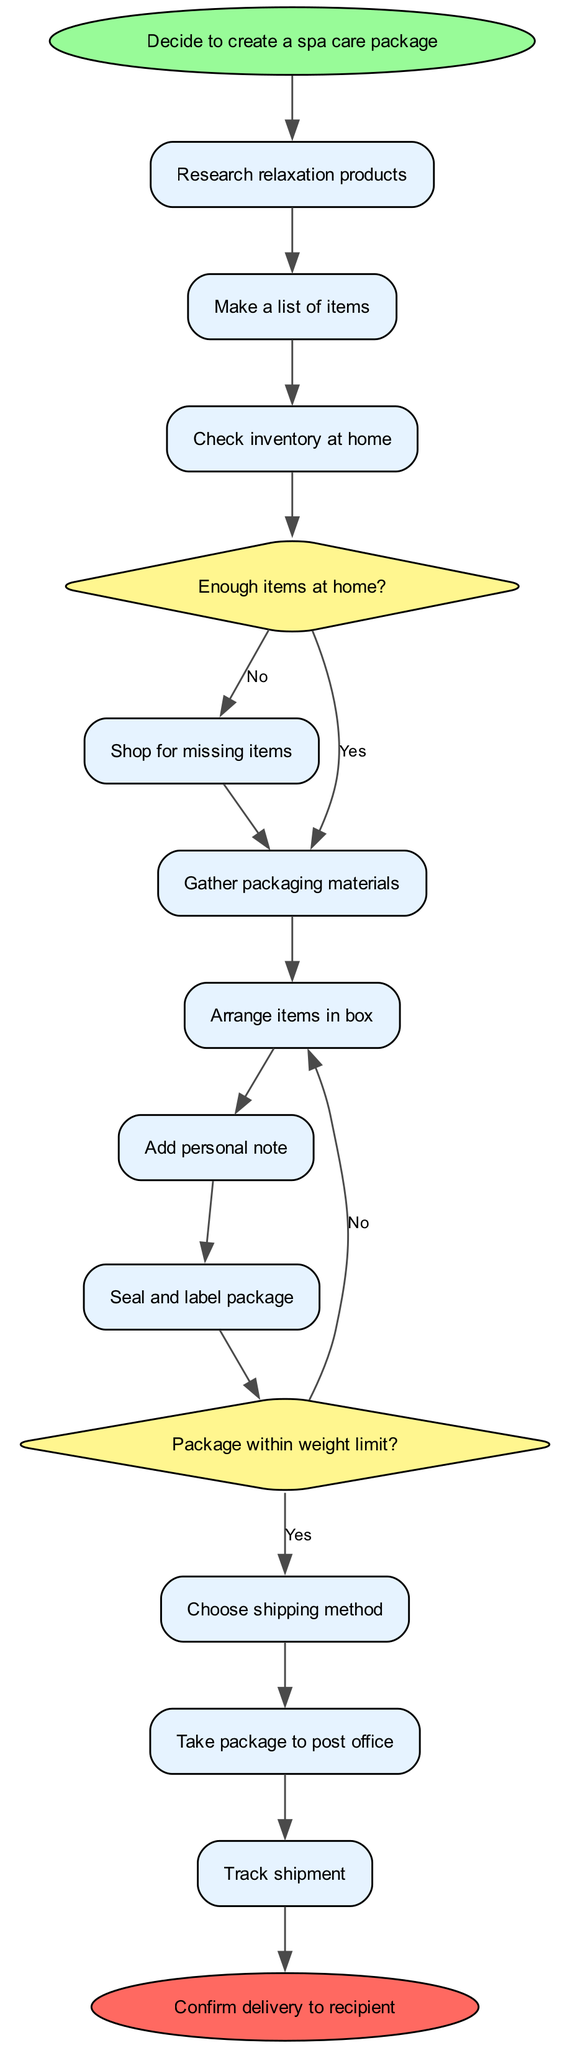What is the first step in the diagram? The first step is indicated by the 'start' node which states "Decide to create a spa care package." This is the initial action in the process.
Answer: Decide to create a spa care package How many activities are listed in the diagram? The diagram lists a total of 11 activities, including the decision nodes and actions. These activities include all the steps that need to be taken to create and send the package.
Answer: 11 What happens if there are enough items at home? If there are enough items at home, the flow proceeds to "Gather packaging materials" after the decision node checking inventory. This indicates that the participant can skip shopping since their inventory is sufficient.
Answer: Gather packaging materials What is the outcome if the package exceeds the weight limit? If the package exceeds the weight limit during the shipping process, the flow leads back to "Rearrange items in box," suggesting that the items must be adjusted to comply with the shipping rules.
Answer: Rearrange items in box What is the last action in the diagram before confirming delivery? The last action before confirming delivery is "Track shipment." This means the sender checks the status of the package after sending it, ensuring it reaches the recipient.
Answer: Track shipment What type of node is used to represent decisions? Decision nodes in the diagram are represented as diamond shapes, which visually indicate points in the process where a choice needs to be made based on the outcomes of previous actions.
Answer: Diamond What do you do after adding a personal note? After adding a personal note, the flow continues to "Seal and label package." This means the next step is preparing the package for delivery.
Answer: Seal and label package Which step involves checking inventory? The step that involves checking inventory is called "Check inventory at home." This is a crucial decision point that influences whether additional shopping is necessary.
Answer: Check inventory at home 